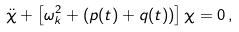Convert formula to latex. <formula><loc_0><loc_0><loc_500><loc_500>\ddot { \chi } + \left [ \omega _ { k } ^ { 2 } + ( p ( t ) + q ( t ) ) \right ] \chi = 0 \, ,</formula> 